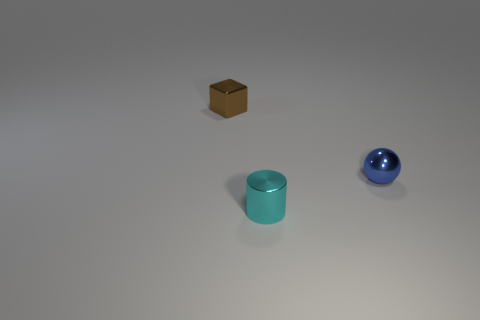Add 3 small shiny cylinders. How many objects exist? 6 Subtract all cubes. How many objects are left? 2 Add 1 metal cylinders. How many metal cylinders exist? 2 Subtract 0 purple cylinders. How many objects are left? 3 Subtract all large blue cylinders. Subtract all shiny blocks. How many objects are left? 2 Add 3 balls. How many balls are left? 4 